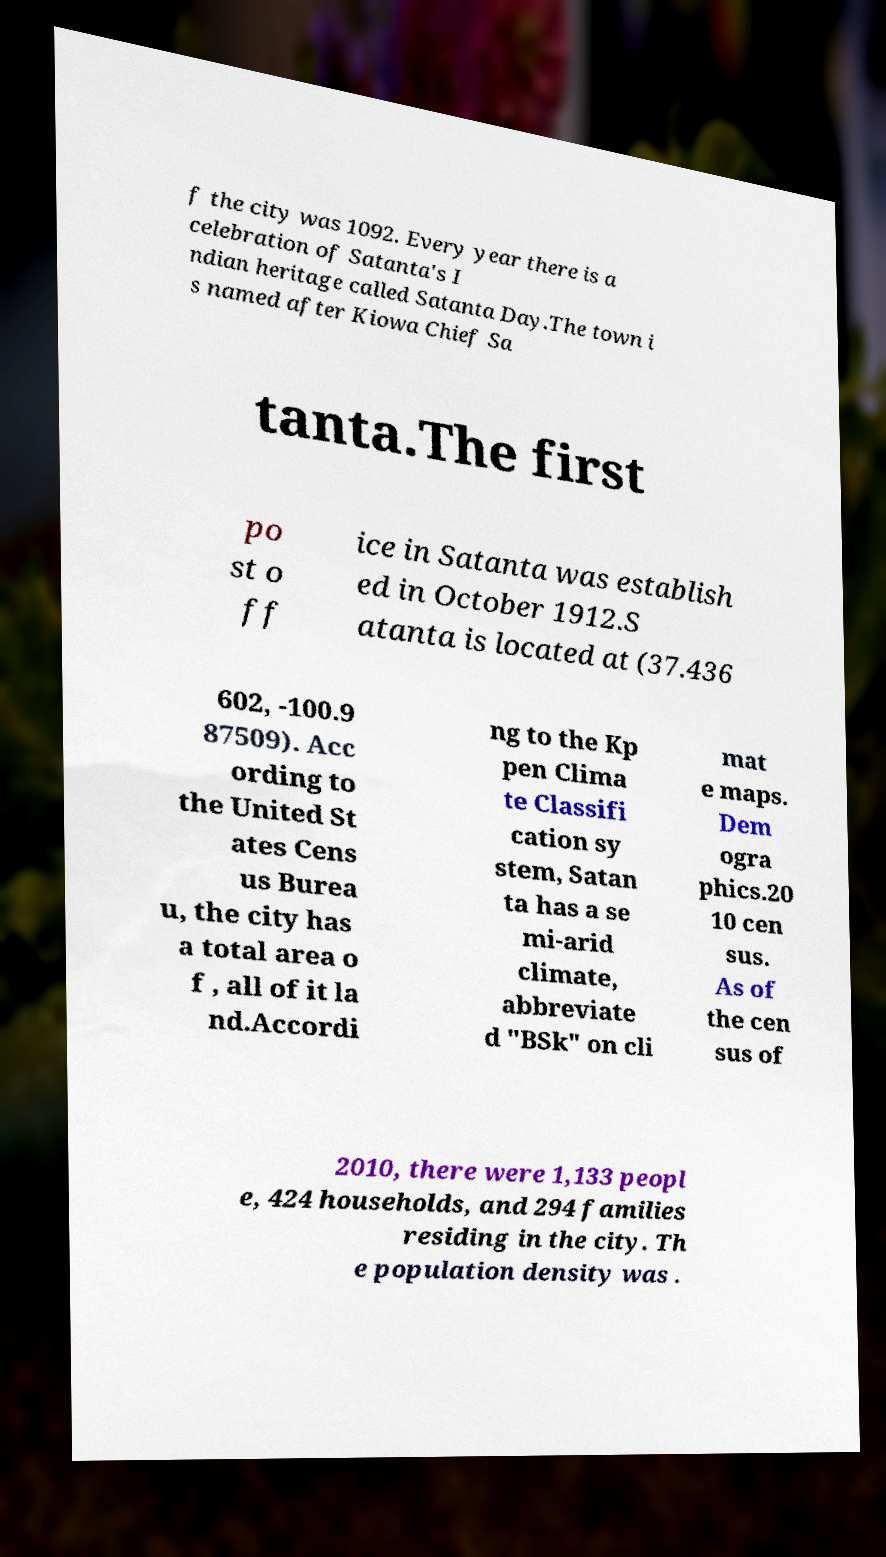I need the written content from this picture converted into text. Can you do that? f the city was 1092. Every year there is a celebration of Satanta's I ndian heritage called Satanta Day.The town i s named after Kiowa Chief Sa tanta.The first po st o ff ice in Satanta was establish ed in October 1912.S atanta is located at (37.436 602, -100.9 87509). Acc ording to the United St ates Cens us Burea u, the city has a total area o f , all of it la nd.Accordi ng to the Kp pen Clima te Classifi cation sy stem, Satan ta has a se mi-arid climate, abbreviate d "BSk" on cli mat e maps. Dem ogra phics.20 10 cen sus. As of the cen sus of 2010, there were 1,133 peopl e, 424 households, and 294 families residing in the city. Th e population density was . 